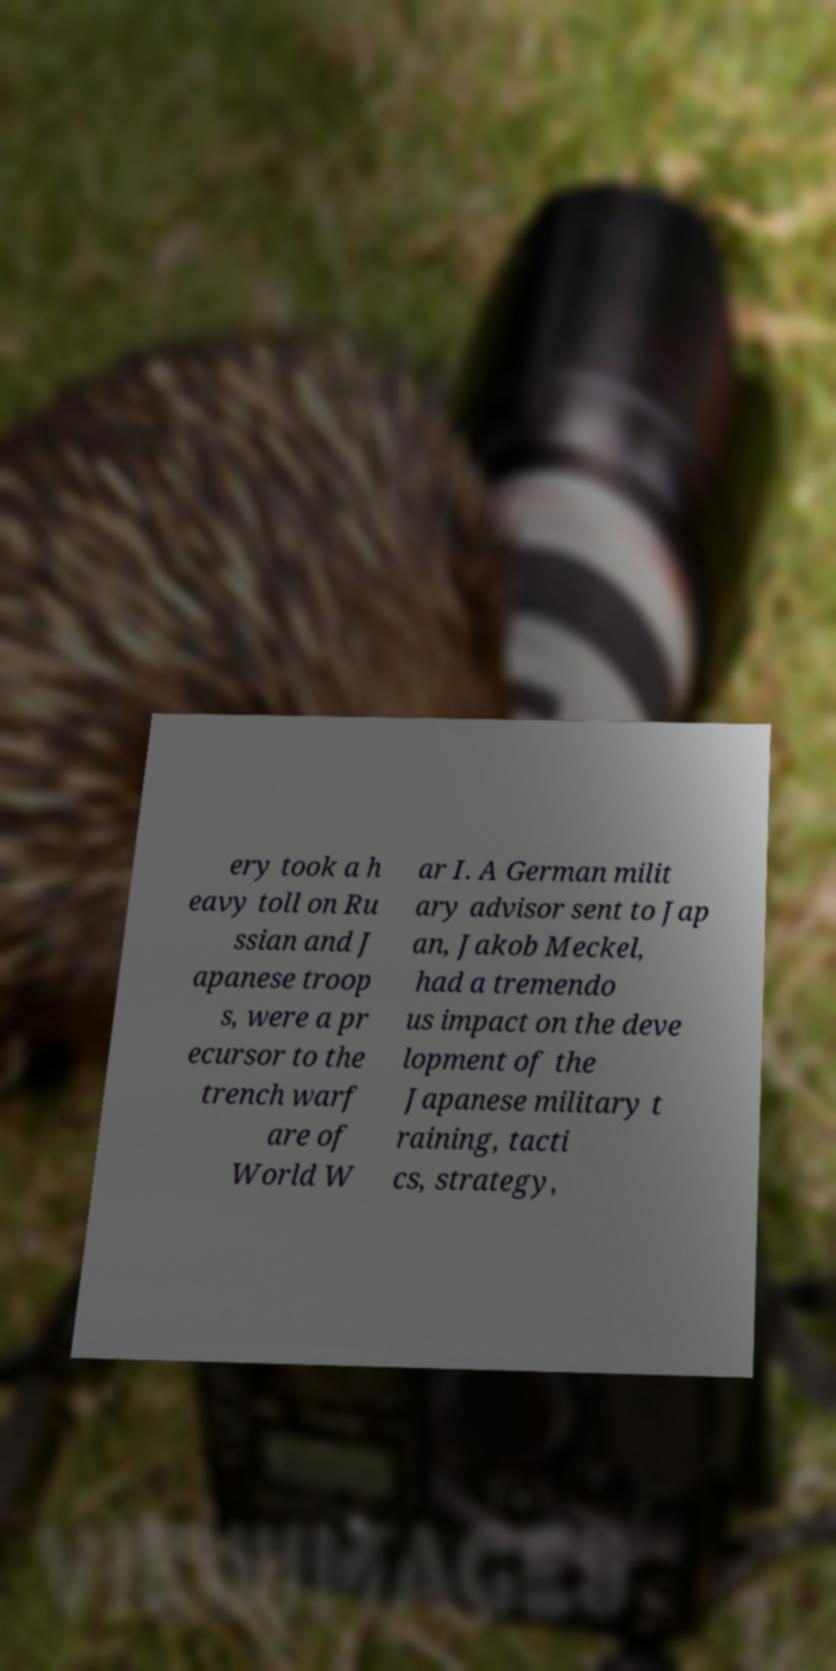Please read and relay the text visible in this image. What does it say? ery took a h eavy toll on Ru ssian and J apanese troop s, were a pr ecursor to the trench warf are of World W ar I. A German milit ary advisor sent to Jap an, Jakob Meckel, had a tremendo us impact on the deve lopment of the Japanese military t raining, tacti cs, strategy, 